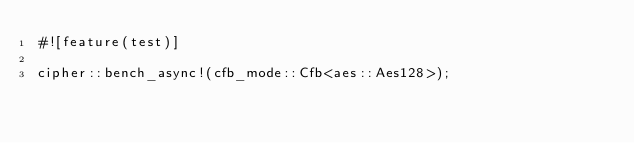Convert code to text. <code><loc_0><loc_0><loc_500><loc_500><_Rust_>#![feature(test)]

cipher::bench_async!(cfb_mode::Cfb<aes::Aes128>);
</code> 